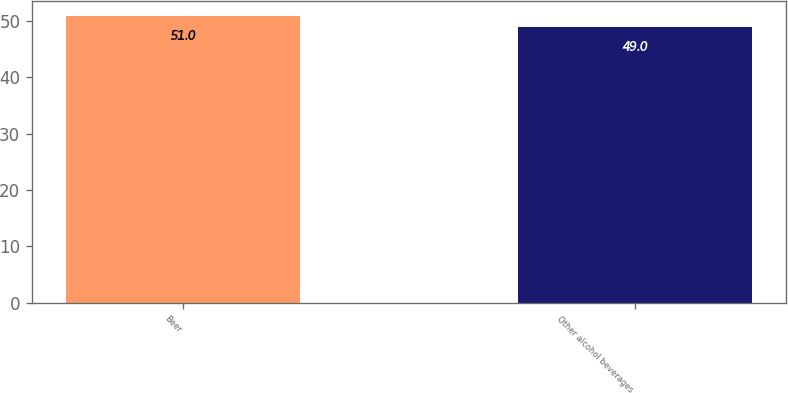<chart> <loc_0><loc_0><loc_500><loc_500><bar_chart><fcel>Beer<fcel>Other alcohol beverages<nl><fcel>51<fcel>49<nl></chart> 